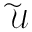Convert formula to latex. <formula><loc_0><loc_0><loc_500><loc_500>\widetilde { \mathcal { U } }</formula> 